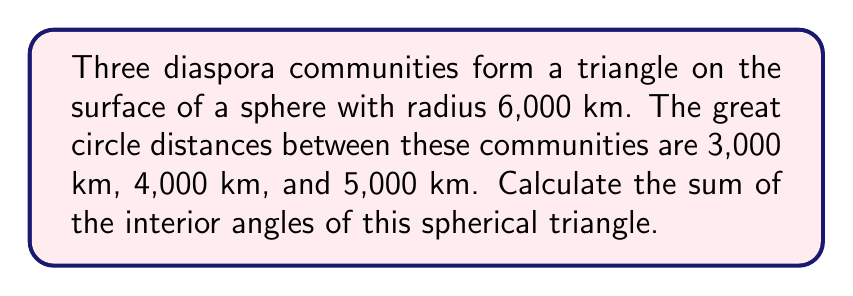Give your solution to this math problem. Let's approach this step-by-step using spherical trigonometry:

1) First, we need to convert the distances to central angles. On a sphere, the central angle $\theta$ (in radians) is related to the arc length $s$ and radius $r$ by the formula:

   $\theta = \frac{s}{r}$

2) Let's calculate the central angles A, B, and C:

   $A = \frac{3000}{6000} = 0.5$ radians
   $B = \frac{4000}{6000} \approx 0.6667$ radians
   $C = \frac{5000}{6000} \approx 0.8333$ radians

3) In spherical geometry, we use the spherical excess formula to find the sum of the interior angles. The spherical excess $E$ is given by:

   $E = A + B + C - \pi$

   Where A, B, and C are the interior angles of the spherical triangle.

4) We can find the interior angles using the spherical cosine law:

   $\cos(a) = \cos(b)\cos(c) + \sin(b)\sin(c)\cos(A)$

   Where a, b, and c are the side lengths (central angles) and A is the opposite angle.

5) Rearranging this for angle A:

   $A = \arccos(\frac{\cos(a) - \cos(b)\cos(c)}{\sin(b)\sin(c)})$

6) Calculating each angle:

   $A = \arccos(\frac{\cos(0.8333) - \cos(0.5)\cos(0.6667)}{\sin(0.5)\sin(0.6667)}) \approx 1.5708$ radians
   $B = \arccos(\frac{\cos(0.5) - \cos(0.6667)\cos(0.8333)}{\sin(0.6667)\sin(0.8333)}) \approx 1.0472$ radians
   $C = \arccos(\frac{\cos(0.6667) - \cos(0.5)\cos(0.8333)}{\sin(0.5)\sin(0.8333)}) \approx 1.3089$ radians

7) Sum of the angles:

   $1.5708 + 1.0472 + 1.3089 \approx 3.9269$ radians

8) Converting to degrees:

   $3.9269 \times \frac{180}{\pi} \approx 225°$
Answer: 225° 